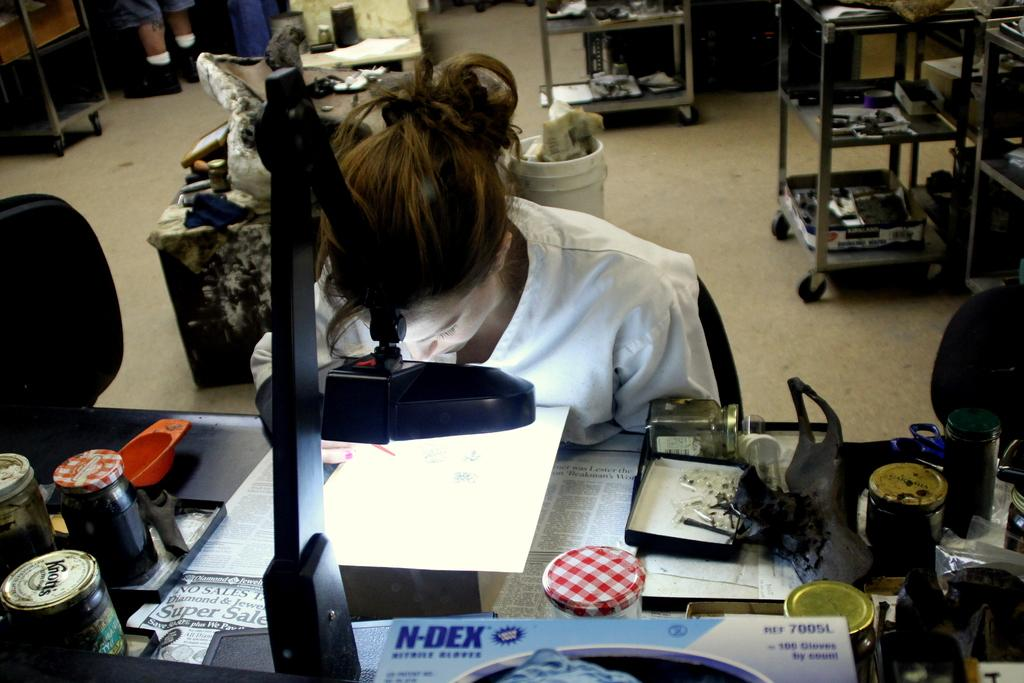<image>
Present a compact description of the photo's key features. A room with a book with the words N-DEX written upon it. 